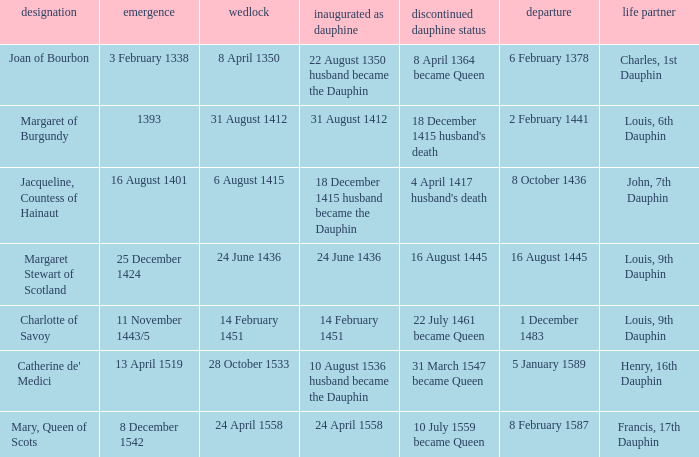When was the death when the birth was 8 december 1542? 8 February 1587. 